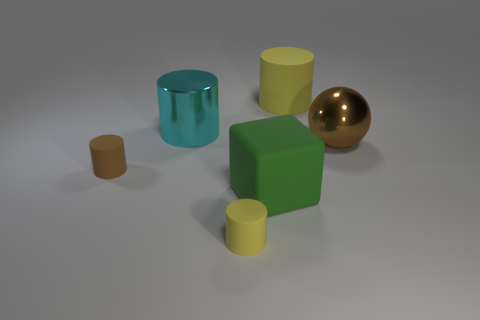How many things are small green rubber cylinders or brown things?
Your response must be concise. 2. Are there any red rubber objects?
Provide a succinct answer. No. What shape is the tiny matte object behind the large green rubber cube in front of the big yellow cylinder?
Provide a succinct answer. Cylinder. What number of objects are shiny objects in front of the cyan thing or matte cylinders right of the small brown rubber thing?
Make the answer very short. 3. What material is the cyan object that is the same size as the rubber cube?
Give a very brief answer. Metal. What color is the large block?
Ensure brevity in your answer.  Green. There is a large thing that is both in front of the large cyan metallic thing and behind the big rubber cube; what material is it made of?
Ensure brevity in your answer.  Metal. Is there a matte object in front of the object right of the rubber cylinder that is behind the big cyan metal cylinder?
Provide a short and direct response. Yes. There is a tiny yellow matte thing; are there any metallic spheres behind it?
Your answer should be compact. Yes. What number of other objects are the same shape as the big green rubber thing?
Your response must be concise. 0. 